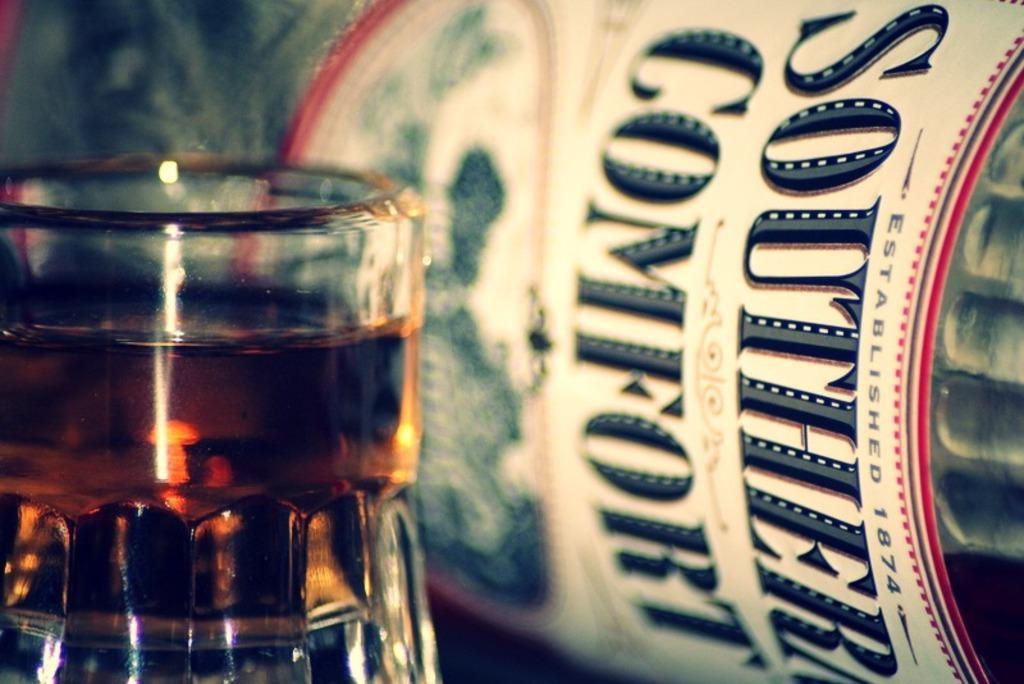Provide a one-sentence caption for the provided image. A bottle of SOUTHERN COMFORT sits on its side behind a short glass filled with liquid. 